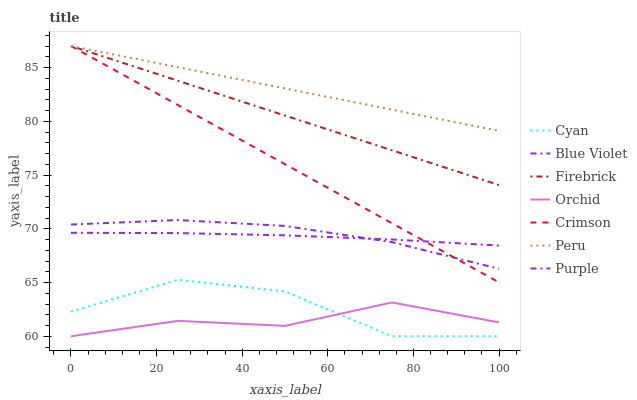Does Orchid have the minimum area under the curve?
Answer yes or no. Yes. Does Peru have the maximum area under the curve?
Answer yes or no. Yes. Does Firebrick have the minimum area under the curve?
Answer yes or no. No. Does Firebrick have the maximum area under the curve?
Answer yes or no. No. Is Firebrick the smoothest?
Answer yes or no. Yes. Is Cyan the roughest?
Answer yes or no. Yes. Is Crimson the smoothest?
Answer yes or no. No. Is Crimson the roughest?
Answer yes or no. No. Does Firebrick have the lowest value?
Answer yes or no. No. Does Crimson have the highest value?
Answer yes or no. Yes. Does Cyan have the highest value?
Answer yes or no. No. Is Purple less than Peru?
Answer yes or no. Yes. Is Peru greater than Blue Violet?
Answer yes or no. Yes. Does Crimson intersect Firebrick?
Answer yes or no. Yes. Is Crimson less than Firebrick?
Answer yes or no. No. Is Crimson greater than Firebrick?
Answer yes or no. No. Does Purple intersect Peru?
Answer yes or no. No. 